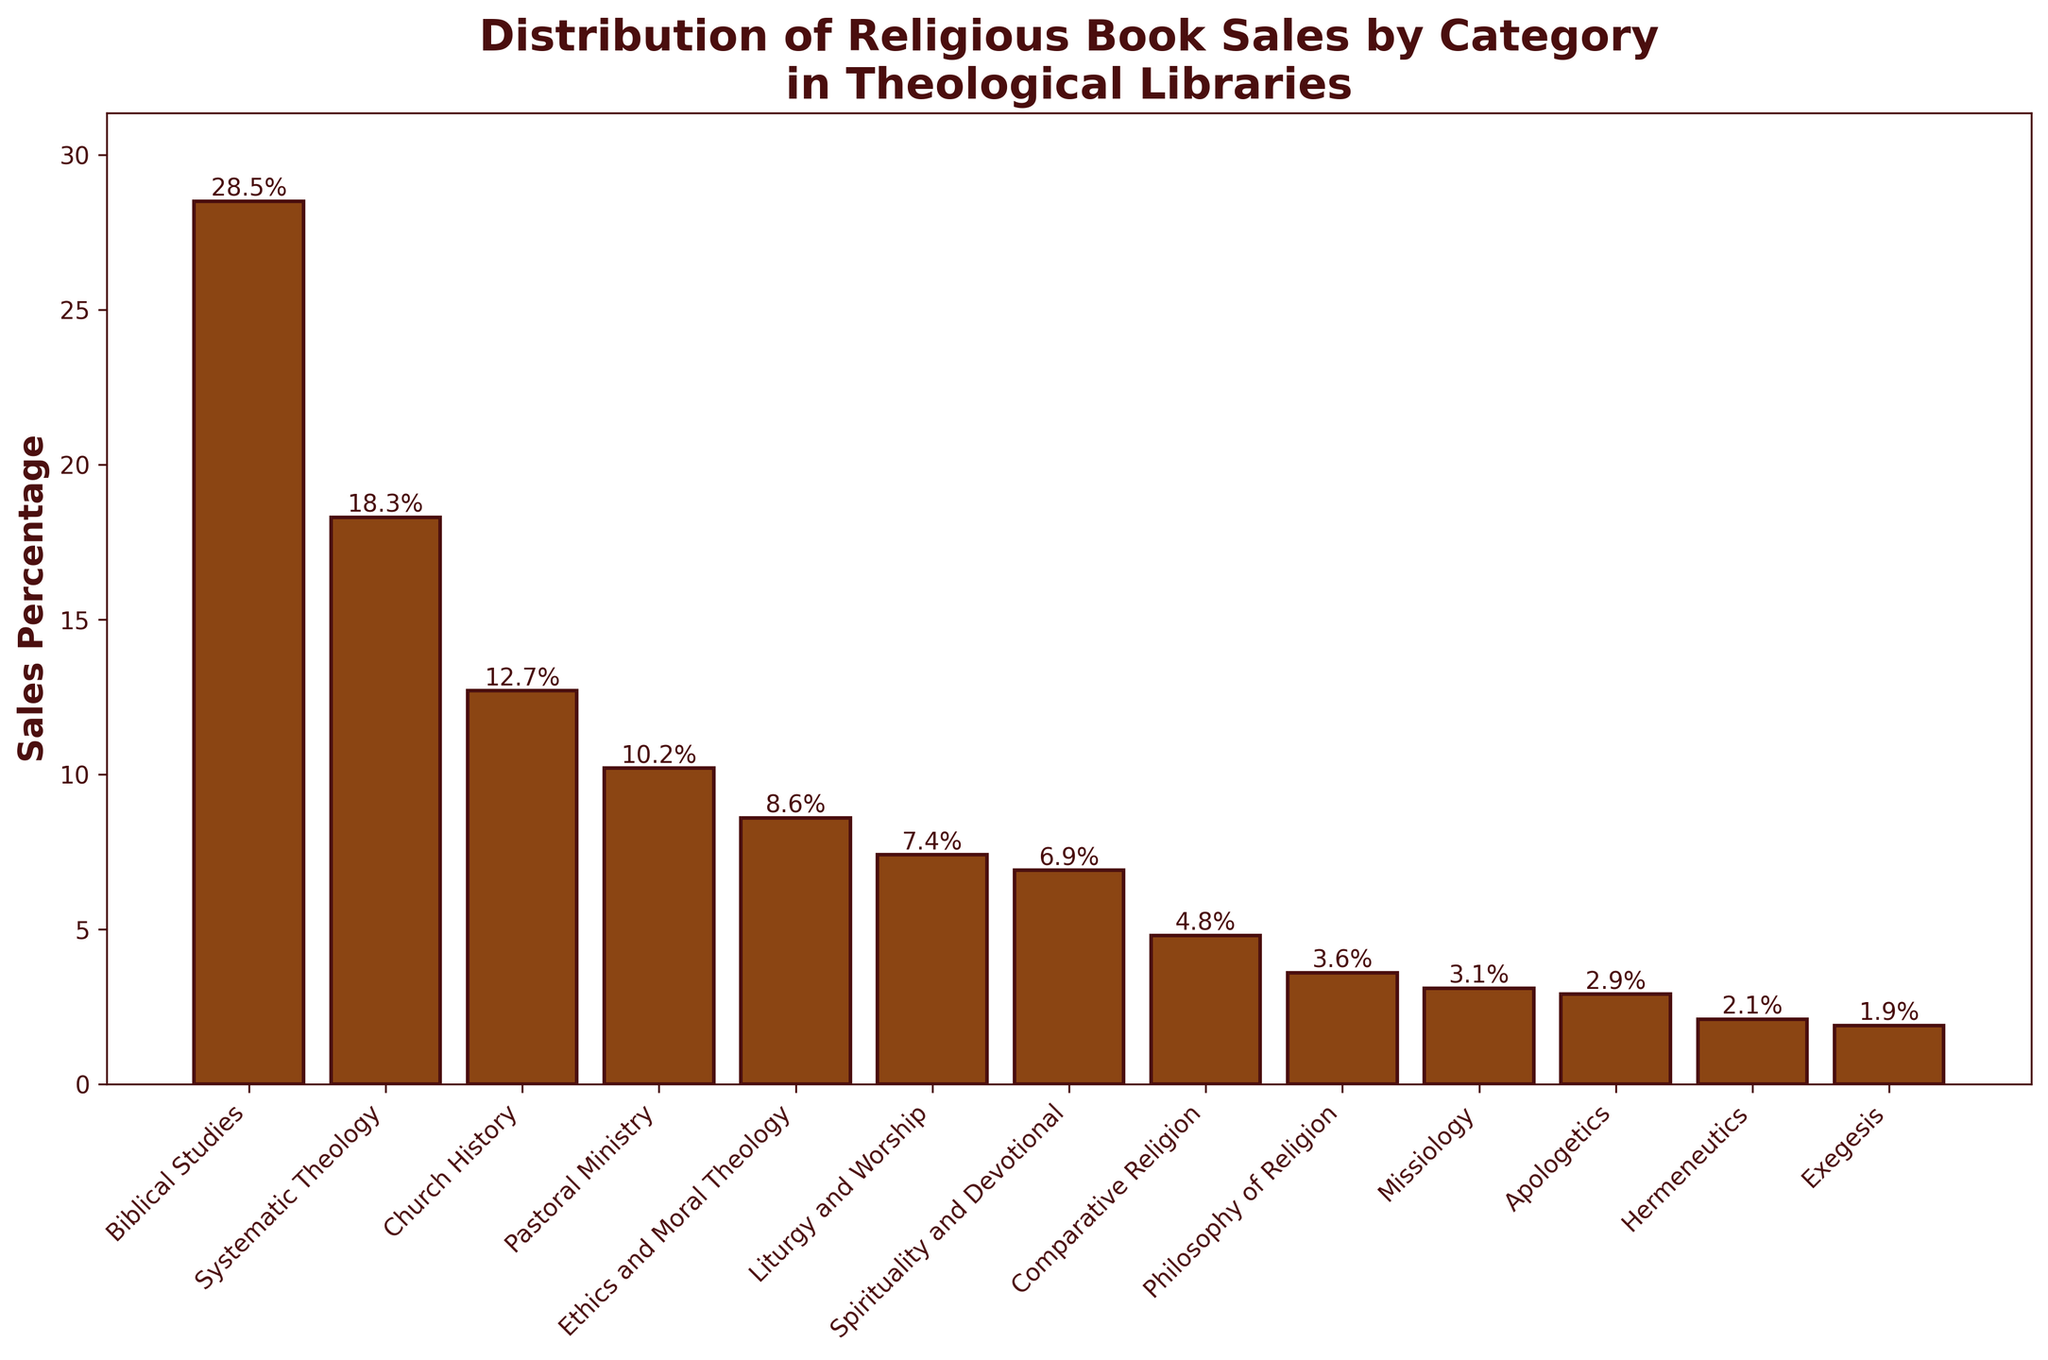What percentage of book sales is attributed to Biblical Studies? Look for the bar labeled "Biblical Studies" and read the percentage given on top of the bar. The label indicates 28.5%.
Answer: 28.5% Which category has the lowest sales percentage? Find the shortest bar in the chart. The category with the shortest bar is "Exegesis" with a percentage of 1.9%.
Answer: Exegesis What is the combined sales percentage of Systematic Theology and Church History? Locate the bars for "Systematic Theology" and "Church History" and add their percentages. Systematic Theology is 18.3% and Church History is 12.7%, totaling 18.3% + 12.7% = 31.0%.
Answer: 31.0% Are the sales percentages of Philosophy of Religion and Missiology greater or less than the sales percentage of Pastoral Ministry? Locate the bars for "Philosophy of Religion" (3.6%), "Missiology" (3.1%), and "Pastoral Ministry" (10.2%). Both Philosophy of Religion and Missiology have lower percentages than Pastoral Ministry.
Answer: Less Which category has a percentage more than 5%, but less than 10%? Identify the bars that have percentages between 5% and 10%. These are labeled "Ethics and Moral Theology" (8.6%), "Liturgy and Worship" (7.4%), and "Spirituality and Devotional" (6.9%).
Answer: Ethics and Moral Theology, Liturgy and Worship, Spirituality and Devotional What is the difference in sales percentage between Apologetics and Hermeneutics? Find the bars for "Apologetics" (2.9%) and "Hermeneutics" (2.1%), and subtract the smaller from the larger: 2.9% - 2.1% = 0.8%.
Answer: 0.8% Which category has a sales percentage closest to 10%? Compare all percentages to 10% and identify the closest one, which is "Pastoral Ministry" with 10.2%.
Answer: Pastoral Ministry How many categories have a sales percentage higher than 7%? Count the bars higher than the 7% mark: "Biblical Studies" (28.5%), "Systematic Theology" (18.3%), "Church History" (12.7%), "Pastoral Ministry" (10.2%), "Ethics and Moral Theology" (8.6%), and "Liturgy and Worship" (7.4%). There are six such categories.
Answer: Six What is the average sales percentage across all categories? Add all the percentages and divide by the number of categories. (28.5 + 18.3 + 12.7 + 10.2 + 8.6 + 7.4 + 6.9 + 4.8 + 3.6 + 3.1 + 2.9 + 2.1 + 1.9) / 13 = 7.5%.
Answer: 7.5% Which categories have exactly equal sales percentages? Check if any bars have the same percentage. None of the categories have exactly equal sales percentages.
Answer: None 